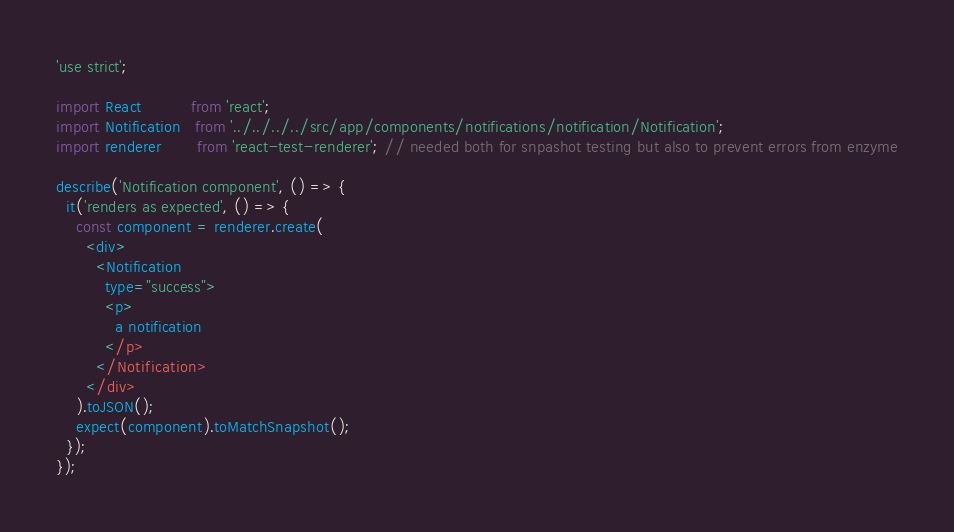Convert code to text. <code><loc_0><loc_0><loc_500><loc_500><_JavaScript_>'use strict';

import React          from 'react';
import Notification   from '../../../../src/app/components/notifications/notification/Notification';
import renderer       from 'react-test-renderer'; // needed both for snpashot testing but also to prevent errors from enzyme

describe('Notification component', () => {
  it('renders as expected', () => {
    const component = renderer.create(
      <div>
        <Notification
          type="success">
          <p>
            a notification
          </p>
        </Notification>
      </div>
    ).toJSON();
    expect(component).toMatchSnapshot();
  });
});
</code> 